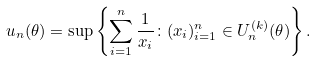Convert formula to latex. <formula><loc_0><loc_0><loc_500><loc_500>u _ { n } ( \theta ) = \sup \left \{ \sum _ { i = 1 } ^ { n } \frac { 1 } { x _ { i } } \colon ( x _ { i } ) _ { i = 1 } ^ { n } \in U _ { n } ^ { ( k ) } ( \theta ) \right \} .</formula> 